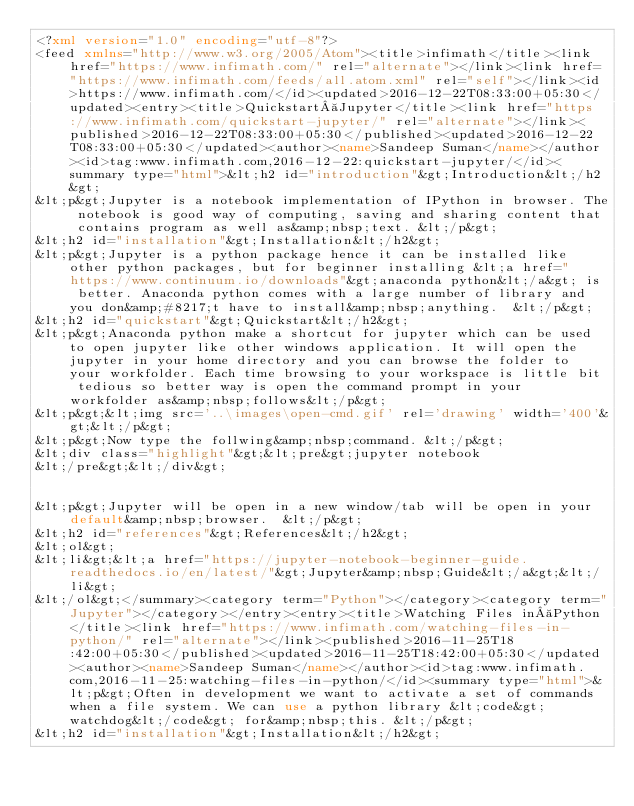<code> <loc_0><loc_0><loc_500><loc_500><_XML_><?xml version="1.0" encoding="utf-8"?>
<feed xmlns="http://www.w3.org/2005/Atom"><title>infimath</title><link href="https://www.infimath.com/" rel="alternate"></link><link href="https://www.infimath.com/feeds/all.atom.xml" rel="self"></link><id>https://www.infimath.com/</id><updated>2016-12-22T08:33:00+05:30</updated><entry><title>Quickstart Jupyter</title><link href="https://www.infimath.com/quickstart-jupyter/" rel="alternate"></link><published>2016-12-22T08:33:00+05:30</published><updated>2016-12-22T08:33:00+05:30</updated><author><name>Sandeep Suman</name></author><id>tag:www.infimath.com,2016-12-22:quickstart-jupyter/</id><summary type="html">&lt;h2 id="introduction"&gt;Introduction&lt;/h2&gt;
&lt;p&gt;Jupyter is a notebook implementation of IPython in browser. The notebook is good way of computing, saving and sharing content that contains program as well as&amp;nbsp;text. &lt;/p&gt;
&lt;h2 id="installation"&gt;Installation&lt;/h2&gt;
&lt;p&gt;Jupyter is a python package hence it can be installed like other python packages, but for beginner installing &lt;a href="https://www.continuum.io/downloads"&gt;anaconda python&lt;/a&gt; is better. Anaconda python comes with a large number of library and you don&amp;#8217;t have to install&amp;nbsp;anything.  &lt;/p&gt;
&lt;h2 id="quickstart"&gt;Quickstart&lt;/h2&gt;
&lt;p&gt;Anaconda python make a shortcut for jupyter which can be used to open jupyter like other windows application. It will open the jupyter in your home directory and you can browse the folder to your workfolder. Each time browsing to your workspace is little bit tedious so better way is open the command prompt in your workfolder as&amp;nbsp;follows&lt;/p&gt;
&lt;p&gt;&lt;img src='..\images\open-cmd.gif' rel='drawing' width='400'&gt;&lt;/p&gt;
&lt;p&gt;Now type the follwing&amp;nbsp;command. &lt;/p&gt;
&lt;div class="highlight"&gt;&lt;pre&gt;jupyter notebook
&lt;/pre&gt;&lt;/div&gt;


&lt;p&gt;Jupyter will be open in a new window/tab will be open in your default&amp;nbsp;browser.  &lt;/p&gt;
&lt;h2 id="references"&gt;References&lt;/h2&gt;
&lt;ol&gt;
&lt;li&gt;&lt;a href="https://jupyter-notebook-beginner-guide.readthedocs.io/en/latest/"&gt;Jupyter&amp;nbsp;Guide&lt;/a&gt;&lt;/li&gt;
&lt;/ol&gt;</summary><category term="Python"></category><category term="Jupyter"></category></entry><entry><title>Watching Files in Python</title><link href="https://www.infimath.com/watching-files-in-python/" rel="alternate"></link><published>2016-11-25T18:42:00+05:30</published><updated>2016-11-25T18:42:00+05:30</updated><author><name>Sandeep Suman</name></author><id>tag:www.infimath.com,2016-11-25:watching-files-in-python/</id><summary type="html">&lt;p&gt;Often in development we want to activate a set of commands when a file system. We can use a python library &lt;code&gt;watchdog&lt;/code&gt; for&amp;nbsp;this. &lt;/p&gt;
&lt;h2 id="installation"&gt;Installation&lt;/h2&gt;</code> 